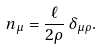Convert formula to latex. <formula><loc_0><loc_0><loc_500><loc_500>n _ { \mu } = \frac { \ell } { 2 \rho } \, \delta _ { \mu \rho } .</formula> 